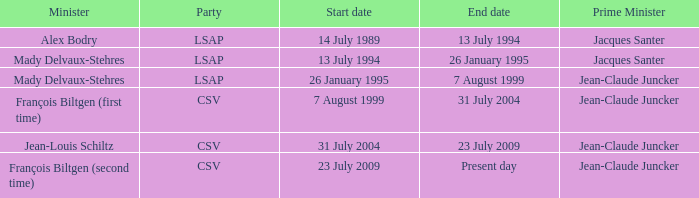What was the end date when Alex Bodry was the minister? 13 July 1994. Would you mind parsing the complete table? {'header': ['Minister', 'Party', 'Start date', 'End date', 'Prime Minister'], 'rows': [['Alex Bodry', 'LSAP', '14 July 1989', '13 July 1994', 'Jacques Santer'], ['Mady Delvaux-Stehres', 'LSAP', '13 July 1994', '26 January 1995', 'Jacques Santer'], ['Mady Delvaux-Stehres', 'LSAP', '26 January 1995', '7 August 1999', 'Jean-Claude Juncker'], ['François Biltgen (first time)', 'CSV', '7 August 1999', '31 July 2004', 'Jean-Claude Juncker'], ['Jean-Louis Schiltz', 'CSV', '31 July 2004', '23 July 2009', 'Jean-Claude Juncker'], ['François Biltgen (second time)', 'CSV', '23 July 2009', 'Present day', 'Jean-Claude Juncker']]} 